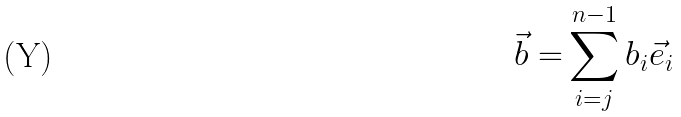<formula> <loc_0><loc_0><loc_500><loc_500>\vec { b } = & \sum _ { i = j } ^ { n - 1 } b _ { i } \vec { e } _ { i }</formula> 